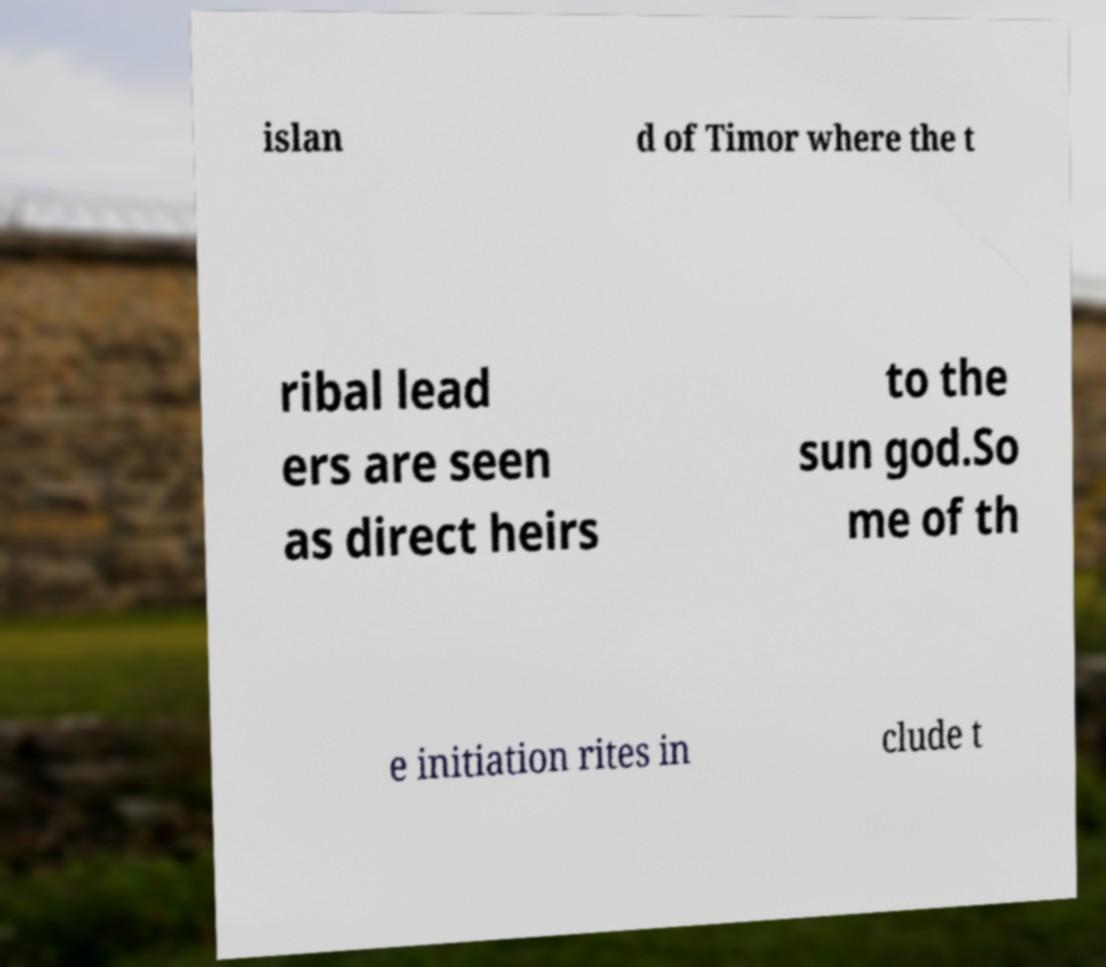Please read and relay the text visible in this image. What does it say? islan d of Timor where the t ribal lead ers are seen as direct heirs to the sun god.So me of th e initiation rites in clude t 